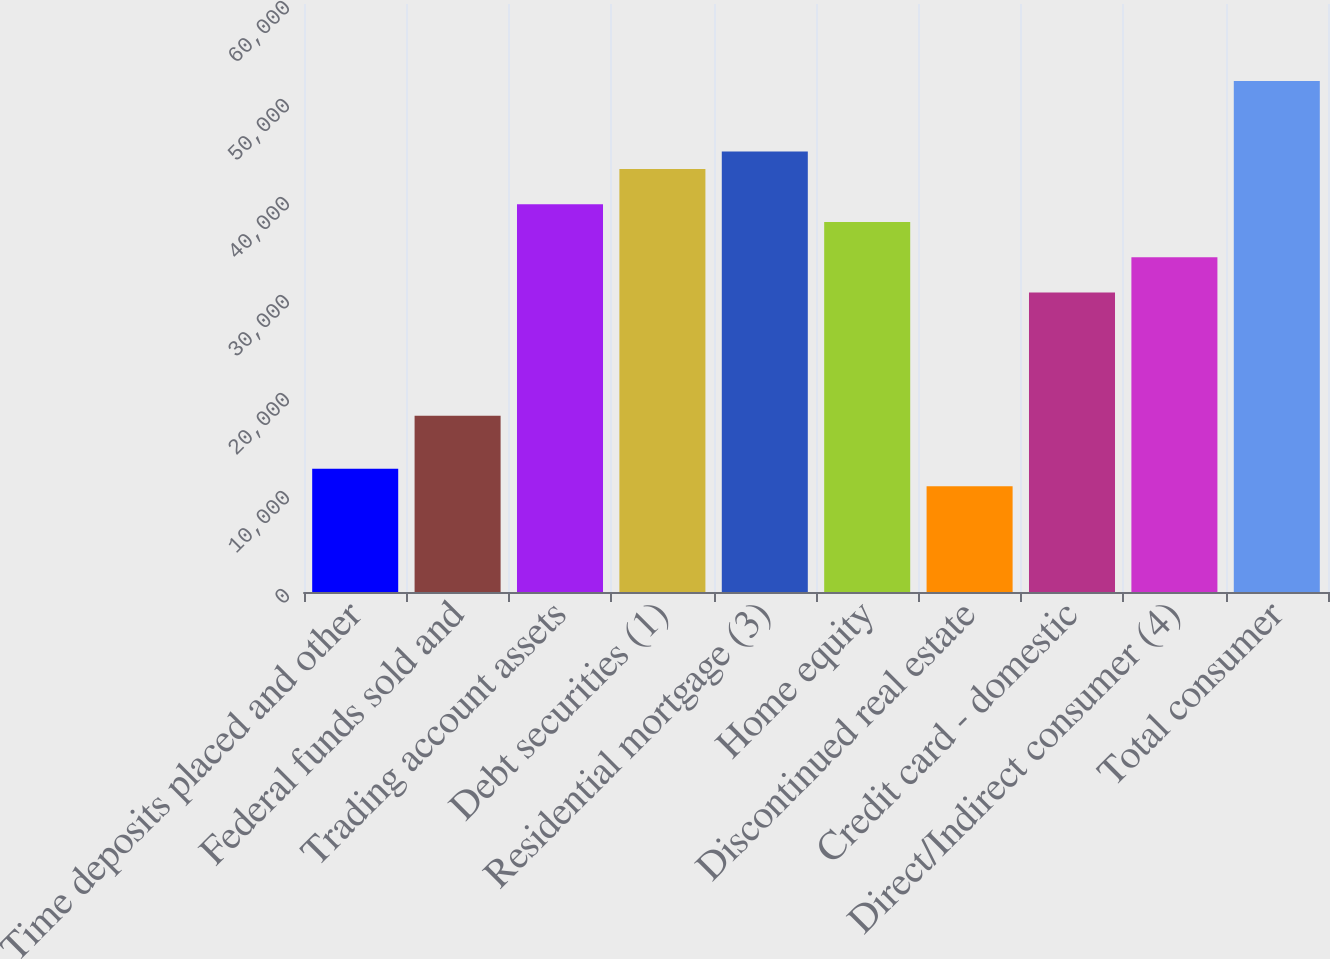<chart> <loc_0><loc_0><loc_500><loc_500><bar_chart><fcel>Time deposits placed and other<fcel>Federal funds sold and<fcel>Trading account assets<fcel>Debt securities (1)<fcel>Residential mortgage (3)<fcel>Home equity<fcel>Discontinued real estate<fcel>Credit card - domestic<fcel>Direct/Indirect consumer (4)<fcel>Total consumer<nl><fcel>12588.6<fcel>17982<fcel>39555.6<fcel>43151.2<fcel>44949<fcel>37757.8<fcel>10790.8<fcel>30566.6<fcel>34162.2<fcel>52140.2<nl></chart> 